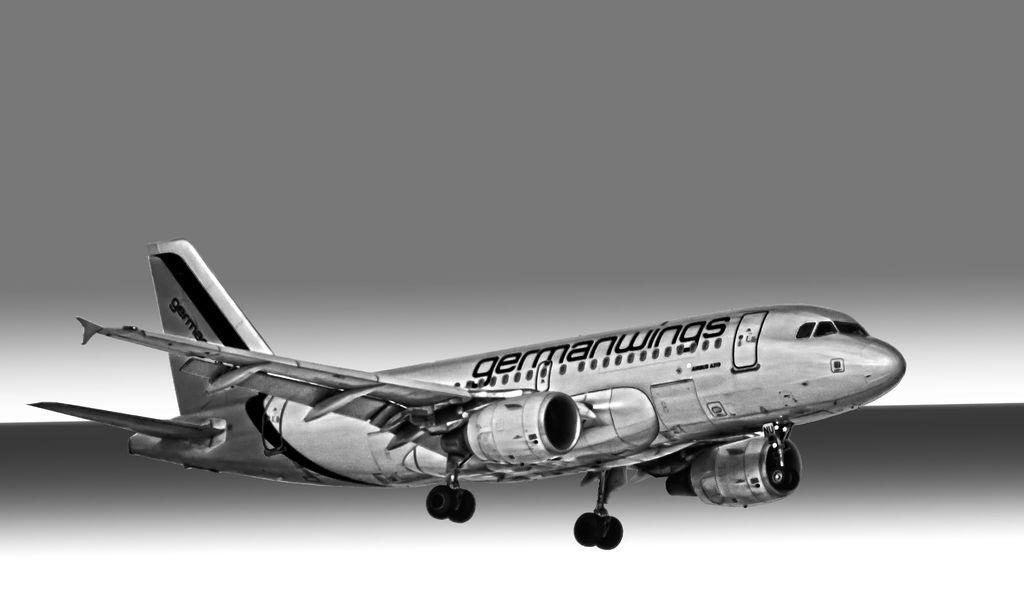Please provide a concise description of this image. In the center of the image we can see an aeroplane. 